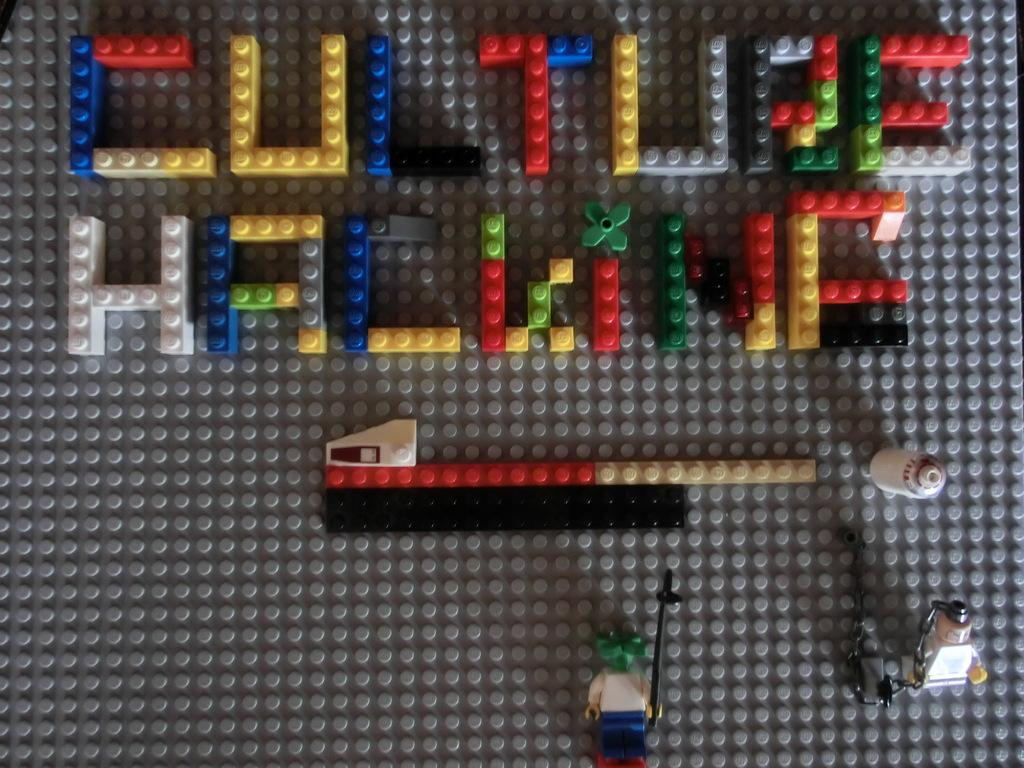What type of objects are present in the image? There are building blocks and toys in the image. Can you describe the location of the building blocks? The building blocks are not specifically mentioned as being at the top or bottom of the image, but they are mentioned before the toys, so it can be inferred that they are higher up in the image. What type of toys are visible at the bottom of the image? The toys at the bottom of the image are not described in detail, so we cannot determine their specific type. What type of cheese is being used to hang the toys in the image? There is no cheese present in the image, and the toys are not being hung. 